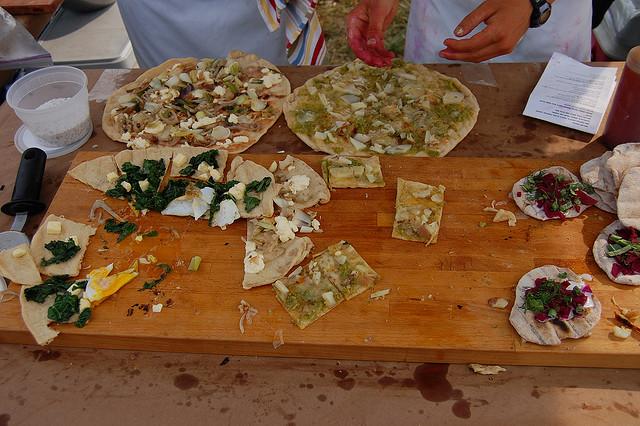What kind of surface is the food on?
Keep it brief. Wood. How long did it take the people to prepare this food?
Be succinct. Not long. Where are the pizza?
Concise answer only. Table. Is this area clean?
Short answer required. No. 